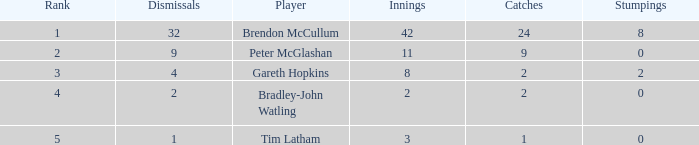How many innings had a total of 2 catches and 0 stumpings? 1.0. 